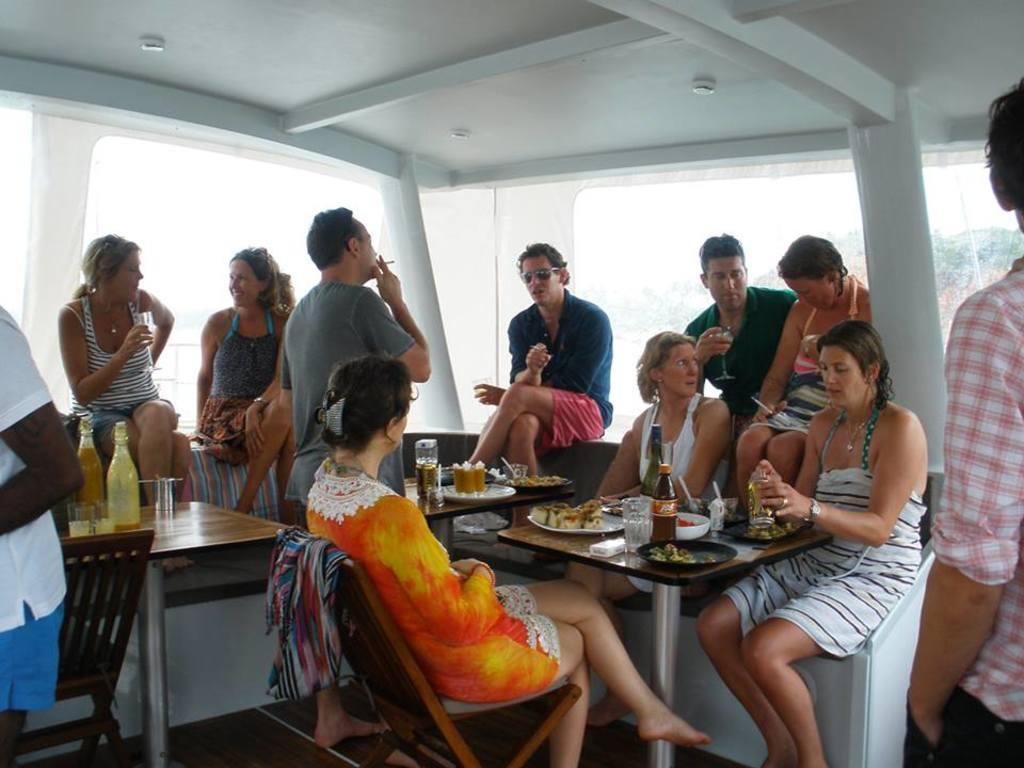Could you give a brief overview of what you see in this image? In this picture, we see many people. In the middle of the picture, we see dining table on which plate, glass is placed on it and we can even see bench and behind them, we see a window from which we can see trees. 